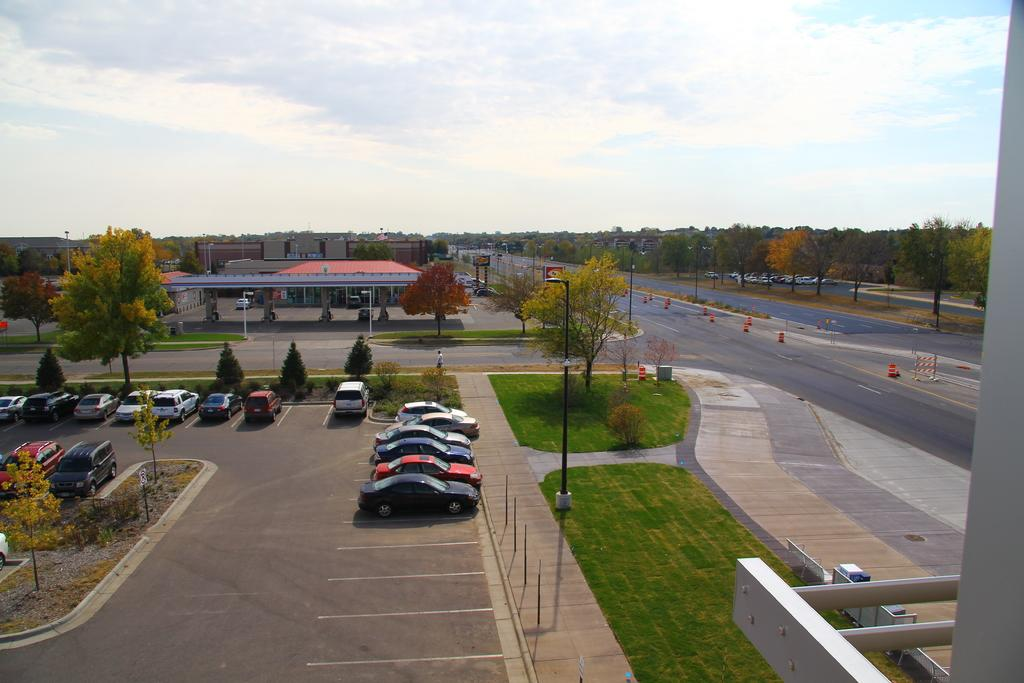What type of structures can be seen in the image? There are buildings in the image. What else is visible besides the buildings? There are vehicles, traffic cones, trees, sign boards, grass, poles, and the sky visible in the image. What might be used to direct traffic in the image? Traffic cones are present in the image for directing traffic. What type of vegetation is present in the image? Trees and grass are present in the image. Can you tell me how many robins are sitting on the poles in the image? There are no robins present in the image; it features buildings, vehicles, traffic cones, trees, sign boards, grass, poles, and the sky. What type of straw is used to build the buildings in the image? The buildings in the image are not made of straw; they are likely made of more traditional materials like brick, concrete, or wood. 